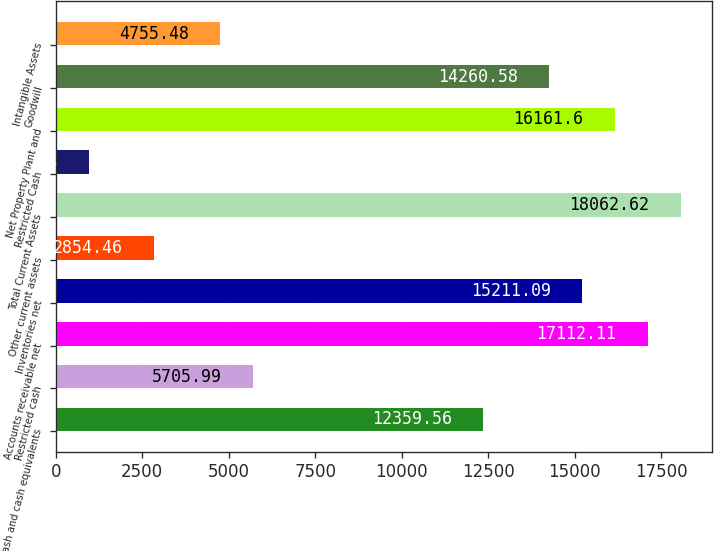<chart> <loc_0><loc_0><loc_500><loc_500><bar_chart><fcel>Cash and cash equivalents<fcel>Restricted cash<fcel>Accounts receivable net<fcel>Inventories net<fcel>Other current assets<fcel>Total Current Assets<fcel>Restricted Cash<fcel>Net Property Plant and<fcel>Goodwill<fcel>Intangible Assets<nl><fcel>12359.6<fcel>5705.99<fcel>17112.1<fcel>15211.1<fcel>2854.46<fcel>18062.6<fcel>953.44<fcel>16161.6<fcel>14260.6<fcel>4755.48<nl></chart> 